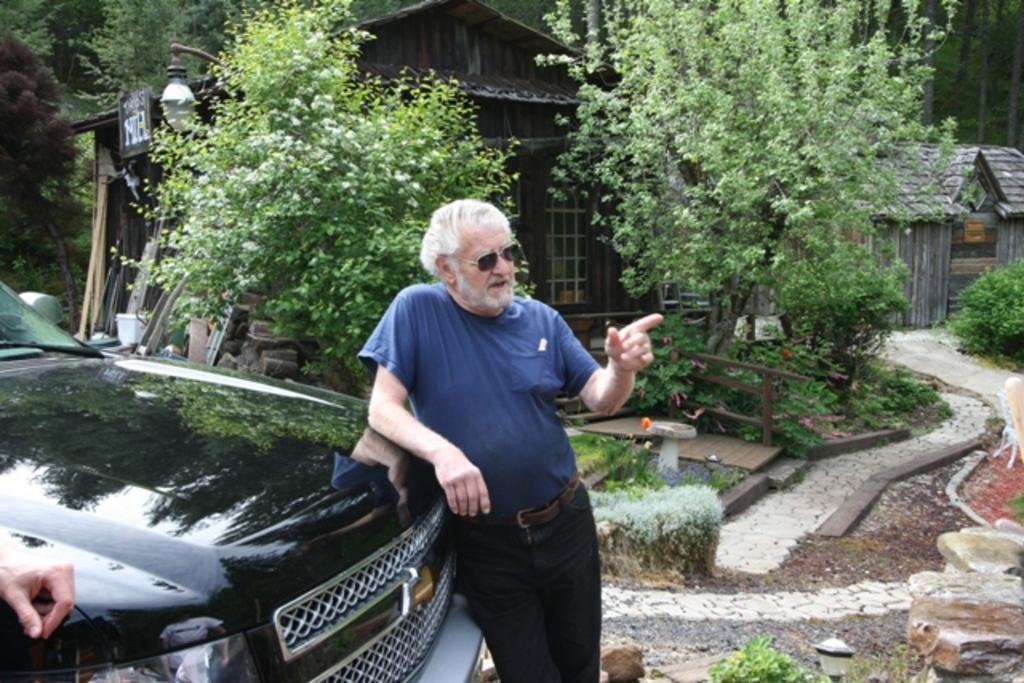In one or two sentences, can you explain what this image depicts? This image is taken outdoors. In the background there are many trees with leaves, stems and branches. There are two huts. There is a light and there is a board with a text on it. There are a few stones and there are a few trees and plants on the ground. On the right side of the image there is a ground and there is a floor. There are a few rocks. On the left side of the image there is a person and a car is parked on the ground. The car is black in color. In the middle of the image a man is standing. 